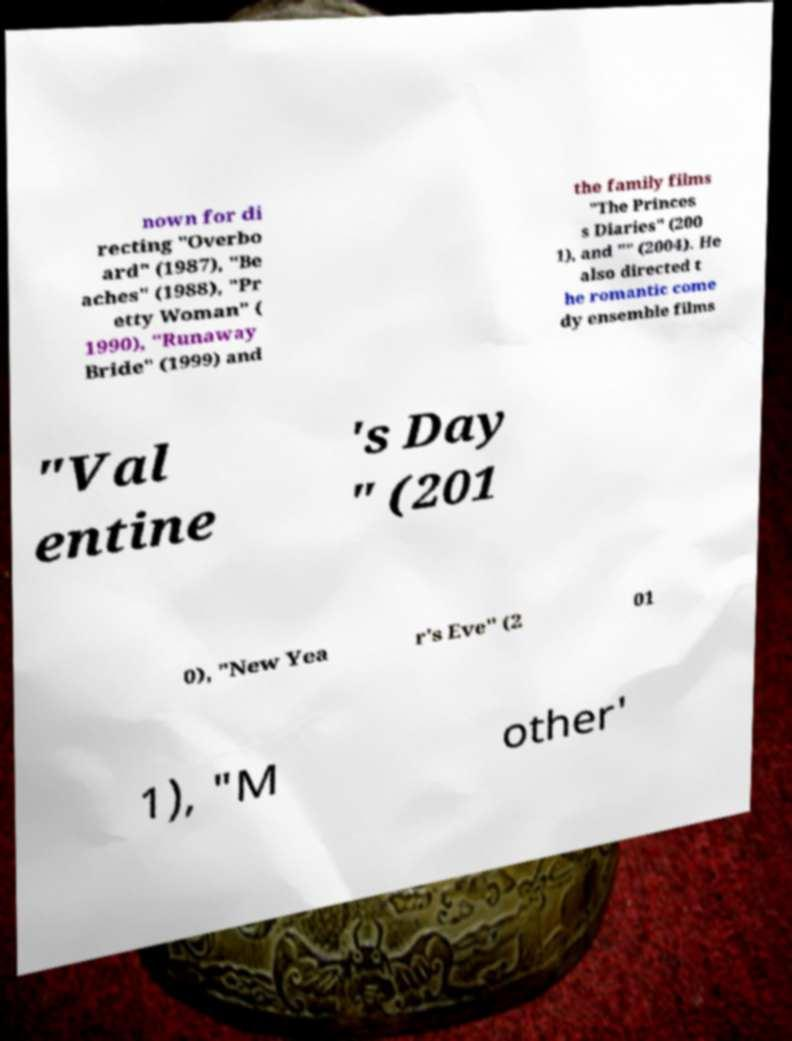There's text embedded in this image that I need extracted. Can you transcribe it verbatim? nown for di recting "Overbo ard" (1987), "Be aches" (1988), "Pr etty Woman" ( 1990), "Runaway Bride" (1999) and the family films "The Princes s Diaries" (200 1), and "" (2004). He also directed t he romantic come dy ensemble films "Val entine 's Day " (201 0), "New Yea r's Eve" (2 01 1), "M other' 